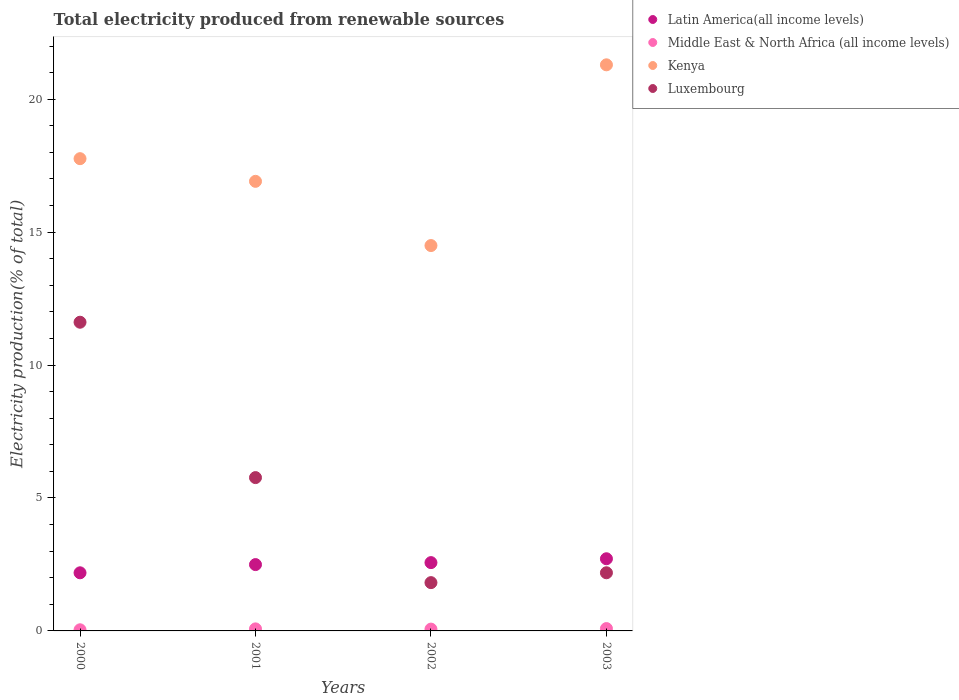How many different coloured dotlines are there?
Offer a terse response. 4. What is the total electricity produced in Luxembourg in 2000?
Your answer should be compact. 11.61. Across all years, what is the maximum total electricity produced in Luxembourg?
Make the answer very short. 11.61. Across all years, what is the minimum total electricity produced in Luxembourg?
Keep it short and to the point. 1.82. In which year was the total electricity produced in Kenya maximum?
Offer a very short reply. 2003. What is the total total electricity produced in Middle East & North Africa (all income levels) in the graph?
Offer a terse response. 0.28. What is the difference between the total electricity produced in Luxembourg in 2000 and that in 2002?
Provide a succinct answer. 9.8. What is the difference between the total electricity produced in Luxembourg in 2002 and the total electricity produced in Middle East & North Africa (all income levels) in 2003?
Your response must be concise. 1.73. What is the average total electricity produced in Luxembourg per year?
Your response must be concise. 5.35. In the year 2001, what is the difference between the total electricity produced in Kenya and total electricity produced in Latin America(all income levels)?
Provide a succinct answer. 14.42. What is the ratio of the total electricity produced in Kenya in 2000 to that in 2002?
Your response must be concise. 1.23. Is the total electricity produced in Luxembourg in 2000 less than that in 2001?
Your answer should be compact. No. Is the difference between the total electricity produced in Kenya in 2001 and 2003 greater than the difference between the total electricity produced in Latin America(all income levels) in 2001 and 2003?
Provide a succinct answer. No. What is the difference between the highest and the second highest total electricity produced in Latin America(all income levels)?
Provide a succinct answer. 0.15. What is the difference between the highest and the lowest total electricity produced in Kenya?
Provide a succinct answer. 6.8. Is it the case that in every year, the sum of the total electricity produced in Latin America(all income levels) and total electricity produced in Luxembourg  is greater than the sum of total electricity produced in Kenya and total electricity produced in Middle East & North Africa (all income levels)?
Offer a very short reply. No. Does the total electricity produced in Luxembourg monotonically increase over the years?
Your response must be concise. No. What is the difference between two consecutive major ticks on the Y-axis?
Give a very brief answer. 5. Are the values on the major ticks of Y-axis written in scientific E-notation?
Provide a short and direct response. No. Does the graph contain grids?
Your answer should be very brief. No. How are the legend labels stacked?
Give a very brief answer. Vertical. What is the title of the graph?
Provide a short and direct response. Total electricity produced from renewable sources. What is the Electricity production(% of total) in Latin America(all income levels) in 2000?
Offer a terse response. 2.19. What is the Electricity production(% of total) of Middle East & North Africa (all income levels) in 2000?
Offer a terse response. 0.04. What is the Electricity production(% of total) of Kenya in 2000?
Keep it short and to the point. 17.76. What is the Electricity production(% of total) of Luxembourg in 2000?
Provide a succinct answer. 11.61. What is the Electricity production(% of total) in Latin America(all income levels) in 2001?
Provide a short and direct response. 2.5. What is the Electricity production(% of total) of Middle East & North Africa (all income levels) in 2001?
Your response must be concise. 0.08. What is the Electricity production(% of total) of Kenya in 2001?
Keep it short and to the point. 16.91. What is the Electricity production(% of total) of Luxembourg in 2001?
Provide a short and direct response. 5.77. What is the Electricity production(% of total) of Latin America(all income levels) in 2002?
Provide a short and direct response. 2.57. What is the Electricity production(% of total) of Middle East & North Africa (all income levels) in 2002?
Your answer should be compact. 0.07. What is the Electricity production(% of total) of Kenya in 2002?
Provide a succinct answer. 14.5. What is the Electricity production(% of total) in Luxembourg in 2002?
Ensure brevity in your answer.  1.82. What is the Electricity production(% of total) of Latin America(all income levels) in 2003?
Make the answer very short. 2.71. What is the Electricity production(% of total) of Middle East & North Africa (all income levels) in 2003?
Your answer should be very brief. 0.09. What is the Electricity production(% of total) in Kenya in 2003?
Your answer should be very brief. 21.29. What is the Electricity production(% of total) in Luxembourg in 2003?
Give a very brief answer. 2.19. Across all years, what is the maximum Electricity production(% of total) in Latin America(all income levels)?
Offer a terse response. 2.71. Across all years, what is the maximum Electricity production(% of total) of Middle East & North Africa (all income levels)?
Your answer should be very brief. 0.09. Across all years, what is the maximum Electricity production(% of total) of Kenya?
Offer a very short reply. 21.29. Across all years, what is the maximum Electricity production(% of total) in Luxembourg?
Offer a very short reply. 11.61. Across all years, what is the minimum Electricity production(% of total) of Latin America(all income levels)?
Make the answer very short. 2.19. Across all years, what is the minimum Electricity production(% of total) of Middle East & North Africa (all income levels)?
Offer a very short reply. 0.04. Across all years, what is the minimum Electricity production(% of total) in Kenya?
Your answer should be very brief. 14.5. Across all years, what is the minimum Electricity production(% of total) of Luxembourg?
Give a very brief answer. 1.82. What is the total Electricity production(% of total) of Latin America(all income levels) in the graph?
Offer a very short reply. 9.96. What is the total Electricity production(% of total) in Middle East & North Africa (all income levels) in the graph?
Your answer should be compact. 0.28. What is the total Electricity production(% of total) in Kenya in the graph?
Offer a very short reply. 70.46. What is the total Electricity production(% of total) of Luxembourg in the graph?
Your answer should be very brief. 21.38. What is the difference between the Electricity production(% of total) in Latin America(all income levels) in 2000 and that in 2001?
Your answer should be very brief. -0.31. What is the difference between the Electricity production(% of total) of Middle East & North Africa (all income levels) in 2000 and that in 2001?
Provide a short and direct response. -0.03. What is the difference between the Electricity production(% of total) of Kenya in 2000 and that in 2001?
Offer a terse response. 0.85. What is the difference between the Electricity production(% of total) in Luxembourg in 2000 and that in 2001?
Offer a terse response. 5.84. What is the difference between the Electricity production(% of total) in Latin America(all income levels) in 2000 and that in 2002?
Ensure brevity in your answer.  -0.38. What is the difference between the Electricity production(% of total) of Middle East & North Africa (all income levels) in 2000 and that in 2002?
Keep it short and to the point. -0.03. What is the difference between the Electricity production(% of total) in Kenya in 2000 and that in 2002?
Your answer should be very brief. 3.27. What is the difference between the Electricity production(% of total) of Luxembourg in 2000 and that in 2002?
Provide a short and direct response. 9.8. What is the difference between the Electricity production(% of total) of Latin America(all income levels) in 2000 and that in 2003?
Provide a short and direct response. -0.53. What is the difference between the Electricity production(% of total) in Middle East & North Africa (all income levels) in 2000 and that in 2003?
Your answer should be compact. -0.05. What is the difference between the Electricity production(% of total) of Kenya in 2000 and that in 2003?
Give a very brief answer. -3.53. What is the difference between the Electricity production(% of total) in Luxembourg in 2000 and that in 2003?
Provide a short and direct response. 9.42. What is the difference between the Electricity production(% of total) of Latin America(all income levels) in 2001 and that in 2002?
Your response must be concise. -0.07. What is the difference between the Electricity production(% of total) of Middle East & North Africa (all income levels) in 2001 and that in 2002?
Your response must be concise. 0.01. What is the difference between the Electricity production(% of total) of Kenya in 2001 and that in 2002?
Offer a terse response. 2.42. What is the difference between the Electricity production(% of total) of Luxembourg in 2001 and that in 2002?
Keep it short and to the point. 3.95. What is the difference between the Electricity production(% of total) in Latin America(all income levels) in 2001 and that in 2003?
Give a very brief answer. -0.22. What is the difference between the Electricity production(% of total) in Middle East & North Africa (all income levels) in 2001 and that in 2003?
Make the answer very short. -0.01. What is the difference between the Electricity production(% of total) in Kenya in 2001 and that in 2003?
Give a very brief answer. -4.38. What is the difference between the Electricity production(% of total) in Luxembourg in 2001 and that in 2003?
Provide a short and direct response. 3.58. What is the difference between the Electricity production(% of total) of Latin America(all income levels) in 2002 and that in 2003?
Make the answer very short. -0.15. What is the difference between the Electricity production(% of total) of Middle East & North Africa (all income levels) in 2002 and that in 2003?
Offer a terse response. -0.02. What is the difference between the Electricity production(% of total) in Kenya in 2002 and that in 2003?
Ensure brevity in your answer.  -6.8. What is the difference between the Electricity production(% of total) of Luxembourg in 2002 and that in 2003?
Give a very brief answer. -0.37. What is the difference between the Electricity production(% of total) of Latin America(all income levels) in 2000 and the Electricity production(% of total) of Middle East & North Africa (all income levels) in 2001?
Make the answer very short. 2.11. What is the difference between the Electricity production(% of total) in Latin America(all income levels) in 2000 and the Electricity production(% of total) in Kenya in 2001?
Offer a very short reply. -14.72. What is the difference between the Electricity production(% of total) in Latin America(all income levels) in 2000 and the Electricity production(% of total) in Luxembourg in 2001?
Offer a very short reply. -3.58. What is the difference between the Electricity production(% of total) in Middle East & North Africa (all income levels) in 2000 and the Electricity production(% of total) in Kenya in 2001?
Provide a succinct answer. -16.87. What is the difference between the Electricity production(% of total) in Middle East & North Africa (all income levels) in 2000 and the Electricity production(% of total) in Luxembourg in 2001?
Offer a terse response. -5.72. What is the difference between the Electricity production(% of total) of Kenya in 2000 and the Electricity production(% of total) of Luxembourg in 2001?
Keep it short and to the point. 12. What is the difference between the Electricity production(% of total) of Latin America(all income levels) in 2000 and the Electricity production(% of total) of Middle East & North Africa (all income levels) in 2002?
Your answer should be compact. 2.12. What is the difference between the Electricity production(% of total) in Latin America(all income levels) in 2000 and the Electricity production(% of total) in Kenya in 2002?
Give a very brief answer. -12.31. What is the difference between the Electricity production(% of total) of Latin America(all income levels) in 2000 and the Electricity production(% of total) of Luxembourg in 2002?
Make the answer very short. 0.37. What is the difference between the Electricity production(% of total) of Middle East & North Africa (all income levels) in 2000 and the Electricity production(% of total) of Kenya in 2002?
Provide a succinct answer. -14.45. What is the difference between the Electricity production(% of total) of Middle East & North Africa (all income levels) in 2000 and the Electricity production(% of total) of Luxembourg in 2002?
Provide a succinct answer. -1.77. What is the difference between the Electricity production(% of total) of Kenya in 2000 and the Electricity production(% of total) of Luxembourg in 2002?
Your response must be concise. 15.95. What is the difference between the Electricity production(% of total) of Latin America(all income levels) in 2000 and the Electricity production(% of total) of Middle East & North Africa (all income levels) in 2003?
Make the answer very short. 2.1. What is the difference between the Electricity production(% of total) in Latin America(all income levels) in 2000 and the Electricity production(% of total) in Kenya in 2003?
Provide a short and direct response. -19.11. What is the difference between the Electricity production(% of total) in Latin America(all income levels) in 2000 and the Electricity production(% of total) in Luxembourg in 2003?
Ensure brevity in your answer.  -0. What is the difference between the Electricity production(% of total) in Middle East & North Africa (all income levels) in 2000 and the Electricity production(% of total) in Kenya in 2003?
Offer a terse response. -21.25. What is the difference between the Electricity production(% of total) in Middle East & North Africa (all income levels) in 2000 and the Electricity production(% of total) in Luxembourg in 2003?
Provide a short and direct response. -2.14. What is the difference between the Electricity production(% of total) of Kenya in 2000 and the Electricity production(% of total) of Luxembourg in 2003?
Make the answer very short. 15.58. What is the difference between the Electricity production(% of total) of Latin America(all income levels) in 2001 and the Electricity production(% of total) of Middle East & North Africa (all income levels) in 2002?
Give a very brief answer. 2.43. What is the difference between the Electricity production(% of total) of Latin America(all income levels) in 2001 and the Electricity production(% of total) of Kenya in 2002?
Your answer should be very brief. -12. What is the difference between the Electricity production(% of total) of Latin America(all income levels) in 2001 and the Electricity production(% of total) of Luxembourg in 2002?
Offer a very short reply. 0.68. What is the difference between the Electricity production(% of total) of Middle East & North Africa (all income levels) in 2001 and the Electricity production(% of total) of Kenya in 2002?
Provide a short and direct response. -14.42. What is the difference between the Electricity production(% of total) of Middle East & North Africa (all income levels) in 2001 and the Electricity production(% of total) of Luxembourg in 2002?
Keep it short and to the point. -1.74. What is the difference between the Electricity production(% of total) of Kenya in 2001 and the Electricity production(% of total) of Luxembourg in 2002?
Make the answer very short. 15.09. What is the difference between the Electricity production(% of total) of Latin America(all income levels) in 2001 and the Electricity production(% of total) of Middle East & North Africa (all income levels) in 2003?
Provide a succinct answer. 2.41. What is the difference between the Electricity production(% of total) in Latin America(all income levels) in 2001 and the Electricity production(% of total) in Kenya in 2003?
Ensure brevity in your answer.  -18.8. What is the difference between the Electricity production(% of total) of Latin America(all income levels) in 2001 and the Electricity production(% of total) of Luxembourg in 2003?
Provide a short and direct response. 0.31. What is the difference between the Electricity production(% of total) of Middle East & North Africa (all income levels) in 2001 and the Electricity production(% of total) of Kenya in 2003?
Your answer should be very brief. -21.22. What is the difference between the Electricity production(% of total) of Middle East & North Africa (all income levels) in 2001 and the Electricity production(% of total) of Luxembourg in 2003?
Make the answer very short. -2.11. What is the difference between the Electricity production(% of total) in Kenya in 2001 and the Electricity production(% of total) in Luxembourg in 2003?
Give a very brief answer. 14.72. What is the difference between the Electricity production(% of total) in Latin America(all income levels) in 2002 and the Electricity production(% of total) in Middle East & North Africa (all income levels) in 2003?
Provide a short and direct response. 2.48. What is the difference between the Electricity production(% of total) of Latin America(all income levels) in 2002 and the Electricity production(% of total) of Kenya in 2003?
Keep it short and to the point. -18.72. What is the difference between the Electricity production(% of total) in Latin America(all income levels) in 2002 and the Electricity production(% of total) in Luxembourg in 2003?
Make the answer very short. 0.38. What is the difference between the Electricity production(% of total) in Middle East & North Africa (all income levels) in 2002 and the Electricity production(% of total) in Kenya in 2003?
Provide a succinct answer. -21.23. What is the difference between the Electricity production(% of total) of Middle East & North Africa (all income levels) in 2002 and the Electricity production(% of total) of Luxembourg in 2003?
Provide a succinct answer. -2.12. What is the difference between the Electricity production(% of total) in Kenya in 2002 and the Electricity production(% of total) in Luxembourg in 2003?
Keep it short and to the point. 12.31. What is the average Electricity production(% of total) of Latin America(all income levels) per year?
Keep it short and to the point. 2.49. What is the average Electricity production(% of total) in Middle East & North Africa (all income levels) per year?
Provide a short and direct response. 0.07. What is the average Electricity production(% of total) of Kenya per year?
Make the answer very short. 17.62. What is the average Electricity production(% of total) in Luxembourg per year?
Offer a very short reply. 5.35. In the year 2000, what is the difference between the Electricity production(% of total) of Latin America(all income levels) and Electricity production(% of total) of Middle East & North Africa (all income levels)?
Give a very brief answer. 2.14. In the year 2000, what is the difference between the Electricity production(% of total) in Latin America(all income levels) and Electricity production(% of total) in Kenya?
Keep it short and to the point. -15.58. In the year 2000, what is the difference between the Electricity production(% of total) of Latin America(all income levels) and Electricity production(% of total) of Luxembourg?
Make the answer very short. -9.43. In the year 2000, what is the difference between the Electricity production(% of total) of Middle East & North Africa (all income levels) and Electricity production(% of total) of Kenya?
Offer a very short reply. -17.72. In the year 2000, what is the difference between the Electricity production(% of total) in Middle East & North Africa (all income levels) and Electricity production(% of total) in Luxembourg?
Ensure brevity in your answer.  -11.57. In the year 2000, what is the difference between the Electricity production(% of total) of Kenya and Electricity production(% of total) of Luxembourg?
Offer a very short reply. 6.15. In the year 2001, what is the difference between the Electricity production(% of total) of Latin America(all income levels) and Electricity production(% of total) of Middle East & North Africa (all income levels)?
Ensure brevity in your answer.  2.42. In the year 2001, what is the difference between the Electricity production(% of total) in Latin America(all income levels) and Electricity production(% of total) in Kenya?
Your response must be concise. -14.42. In the year 2001, what is the difference between the Electricity production(% of total) in Latin America(all income levels) and Electricity production(% of total) in Luxembourg?
Your answer should be compact. -3.27. In the year 2001, what is the difference between the Electricity production(% of total) in Middle East & North Africa (all income levels) and Electricity production(% of total) in Kenya?
Make the answer very short. -16.83. In the year 2001, what is the difference between the Electricity production(% of total) in Middle East & North Africa (all income levels) and Electricity production(% of total) in Luxembourg?
Give a very brief answer. -5.69. In the year 2001, what is the difference between the Electricity production(% of total) of Kenya and Electricity production(% of total) of Luxembourg?
Offer a terse response. 11.14. In the year 2002, what is the difference between the Electricity production(% of total) of Latin America(all income levels) and Electricity production(% of total) of Middle East & North Africa (all income levels)?
Your answer should be compact. 2.5. In the year 2002, what is the difference between the Electricity production(% of total) of Latin America(all income levels) and Electricity production(% of total) of Kenya?
Ensure brevity in your answer.  -11.93. In the year 2002, what is the difference between the Electricity production(% of total) in Latin America(all income levels) and Electricity production(% of total) in Luxembourg?
Offer a very short reply. 0.75. In the year 2002, what is the difference between the Electricity production(% of total) of Middle East & North Africa (all income levels) and Electricity production(% of total) of Kenya?
Make the answer very short. -14.43. In the year 2002, what is the difference between the Electricity production(% of total) of Middle East & North Africa (all income levels) and Electricity production(% of total) of Luxembourg?
Your answer should be very brief. -1.75. In the year 2002, what is the difference between the Electricity production(% of total) of Kenya and Electricity production(% of total) of Luxembourg?
Your answer should be compact. 12.68. In the year 2003, what is the difference between the Electricity production(% of total) of Latin America(all income levels) and Electricity production(% of total) of Middle East & North Africa (all income levels)?
Ensure brevity in your answer.  2.63. In the year 2003, what is the difference between the Electricity production(% of total) of Latin America(all income levels) and Electricity production(% of total) of Kenya?
Make the answer very short. -18.58. In the year 2003, what is the difference between the Electricity production(% of total) in Latin America(all income levels) and Electricity production(% of total) in Luxembourg?
Your answer should be compact. 0.53. In the year 2003, what is the difference between the Electricity production(% of total) of Middle East & North Africa (all income levels) and Electricity production(% of total) of Kenya?
Provide a short and direct response. -21.21. In the year 2003, what is the difference between the Electricity production(% of total) of Middle East & North Africa (all income levels) and Electricity production(% of total) of Luxembourg?
Your answer should be compact. -2.1. In the year 2003, what is the difference between the Electricity production(% of total) in Kenya and Electricity production(% of total) in Luxembourg?
Provide a succinct answer. 19.11. What is the ratio of the Electricity production(% of total) in Latin America(all income levels) in 2000 to that in 2001?
Your answer should be very brief. 0.88. What is the ratio of the Electricity production(% of total) in Middle East & North Africa (all income levels) in 2000 to that in 2001?
Ensure brevity in your answer.  0.56. What is the ratio of the Electricity production(% of total) in Kenya in 2000 to that in 2001?
Ensure brevity in your answer.  1.05. What is the ratio of the Electricity production(% of total) in Luxembourg in 2000 to that in 2001?
Your answer should be very brief. 2.01. What is the ratio of the Electricity production(% of total) of Latin America(all income levels) in 2000 to that in 2002?
Your answer should be very brief. 0.85. What is the ratio of the Electricity production(% of total) of Middle East & North Africa (all income levels) in 2000 to that in 2002?
Keep it short and to the point. 0.63. What is the ratio of the Electricity production(% of total) in Kenya in 2000 to that in 2002?
Provide a succinct answer. 1.23. What is the ratio of the Electricity production(% of total) of Luxembourg in 2000 to that in 2002?
Ensure brevity in your answer.  6.39. What is the ratio of the Electricity production(% of total) in Latin America(all income levels) in 2000 to that in 2003?
Provide a succinct answer. 0.81. What is the ratio of the Electricity production(% of total) in Middle East & North Africa (all income levels) in 2000 to that in 2003?
Your answer should be very brief. 0.48. What is the ratio of the Electricity production(% of total) of Kenya in 2000 to that in 2003?
Your answer should be very brief. 0.83. What is the ratio of the Electricity production(% of total) in Luxembourg in 2000 to that in 2003?
Your answer should be compact. 5.31. What is the ratio of the Electricity production(% of total) of Latin America(all income levels) in 2001 to that in 2002?
Keep it short and to the point. 0.97. What is the ratio of the Electricity production(% of total) in Middle East & North Africa (all income levels) in 2001 to that in 2002?
Offer a terse response. 1.12. What is the ratio of the Electricity production(% of total) in Luxembourg in 2001 to that in 2002?
Your response must be concise. 3.18. What is the ratio of the Electricity production(% of total) of Latin America(all income levels) in 2001 to that in 2003?
Offer a terse response. 0.92. What is the ratio of the Electricity production(% of total) in Middle East & North Africa (all income levels) in 2001 to that in 2003?
Make the answer very short. 0.87. What is the ratio of the Electricity production(% of total) of Kenya in 2001 to that in 2003?
Provide a succinct answer. 0.79. What is the ratio of the Electricity production(% of total) of Luxembourg in 2001 to that in 2003?
Offer a very short reply. 2.64. What is the ratio of the Electricity production(% of total) in Latin America(all income levels) in 2002 to that in 2003?
Provide a succinct answer. 0.95. What is the ratio of the Electricity production(% of total) of Middle East & North Africa (all income levels) in 2002 to that in 2003?
Ensure brevity in your answer.  0.77. What is the ratio of the Electricity production(% of total) of Kenya in 2002 to that in 2003?
Offer a terse response. 0.68. What is the ratio of the Electricity production(% of total) of Luxembourg in 2002 to that in 2003?
Your response must be concise. 0.83. What is the difference between the highest and the second highest Electricity production(% of total) of Latin America(all income levels)?
Keep it short and to the point. 0.15. What is the difference between the highest and the second highest Electricity production(% of total) of Middle East & North Africa (all income levels)?
Your answer should be compact. 0.01. What is the difference between the highest and the second highest Electricity production(% of total) of Kenya?
Your response must be concise. 3.53. What is the difference between the highest and the second highest Electricity production(% of total) of Luxembourg?
Provide a short and direct response. 5.84. What is the difference between the highest and the lowest Electricity production(% of total) in Latin America(all income levels)?
Provide a short and direct response. 0.53. What is the difference between the highest and the lowest Electricity production(% of total) in Middle East & North Africa (all income levels)?
Your response must be concise. 0.05. What is the difference between the highest and the lowest Electricity production(% of total) in Kenya?
Offer a very short reply. 6.8. What is the difference between the highest and the lowest Electricity production(% of total) in Luxembourg?
Your response must be concise. 9.8. 